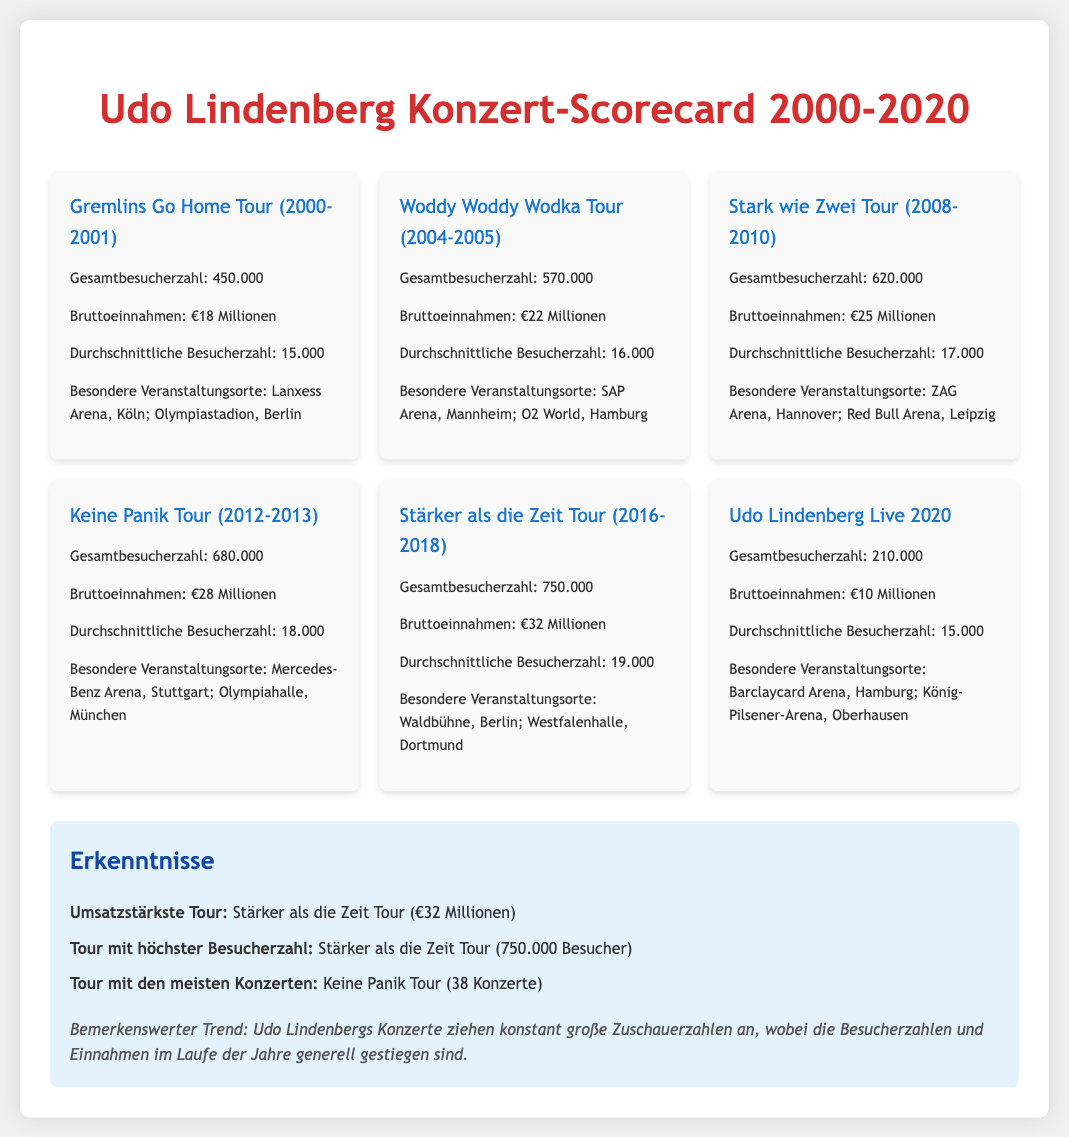What was the total attendance for the Stark wie Zwei Tour? The total attendance is specified directly in the document for the Stark wie Zwei Tour, which states 620.000.
Answer: 620.000 What were the total revenues for the Keine Panik Tour? The total revenue for the Keine Panik Tour is given in the document, which states €28 Millionen.
Answer: €28 Millionen Which tour had the highest average attendance? The highest average attendance can be deduced by comparing the average numbers mentioned in the document, which shows that Stärker als die Zeit Tour had the highest at 19.000.
Answer: 19.000 What is the highlight venue for the Woddy Woddy Wodka Tour? The highlight venue for the Woddy Woddy Wodka Tour is mentioned in the document as O2 World, Hamburg.
Answer: O2 World, Hamburg How many concerts were in the Keine Panik Tour? The document states that the Keine Panik Tour had 38 concerts, which allows us to directly answer this question.
Answer: 38 What was the total revenue for the Udo Lindenberg Live 2020 concert? The total revenue is clearly indicated in the document, stating €10 Millionen.
Answer: €10 Millionen Which tour had the least total attendance? By reviewing the document and comparing the total attendance figures, the least is found to be the Udo Lindenberg Live 2020 concert with 210.000 attendees.
Answer: 210.000 What were the notable venues for the Stärker als die Zeit Tour? The document lists notable venues for the Stärker als die Zeit Tour as Waldbühne, Berlin and Westfalenhalle, Dortmund.
Answer: Waldbühne, Berlin; Westfalenhalle, Dortmund Which tour generated the most revenue? The document specifies that the tour with the most revenue is the Stärker als die Zeit Tour, with €32 Millionen.
Answer: €32 Millionen 